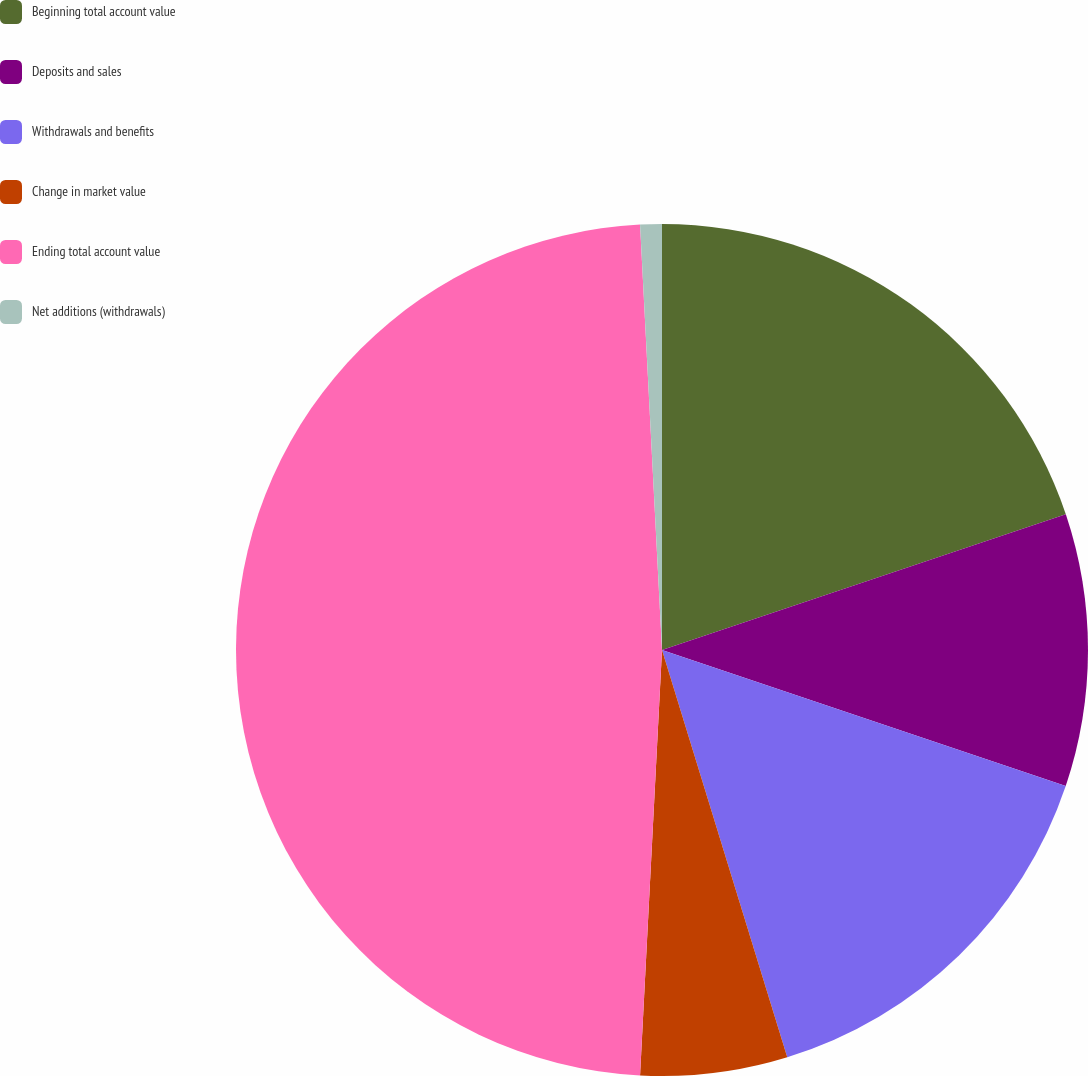Convert chart. <chart><loc_0><loc_0><loc_500><loc_500><pie_chart><fcel>Beginning total account value<fcel>Deposits and sales<fcel>Withdrawals and benefits<fcel>Change in market value<fcel>Ending total account value<fcel>Net additions (withdrawals)<nl><fcel>19.84%<fcel>10.33%<fcel>15.08%<fcel>5.57%<fcel>48.36%<fcel>0.82%<nl></chart> 